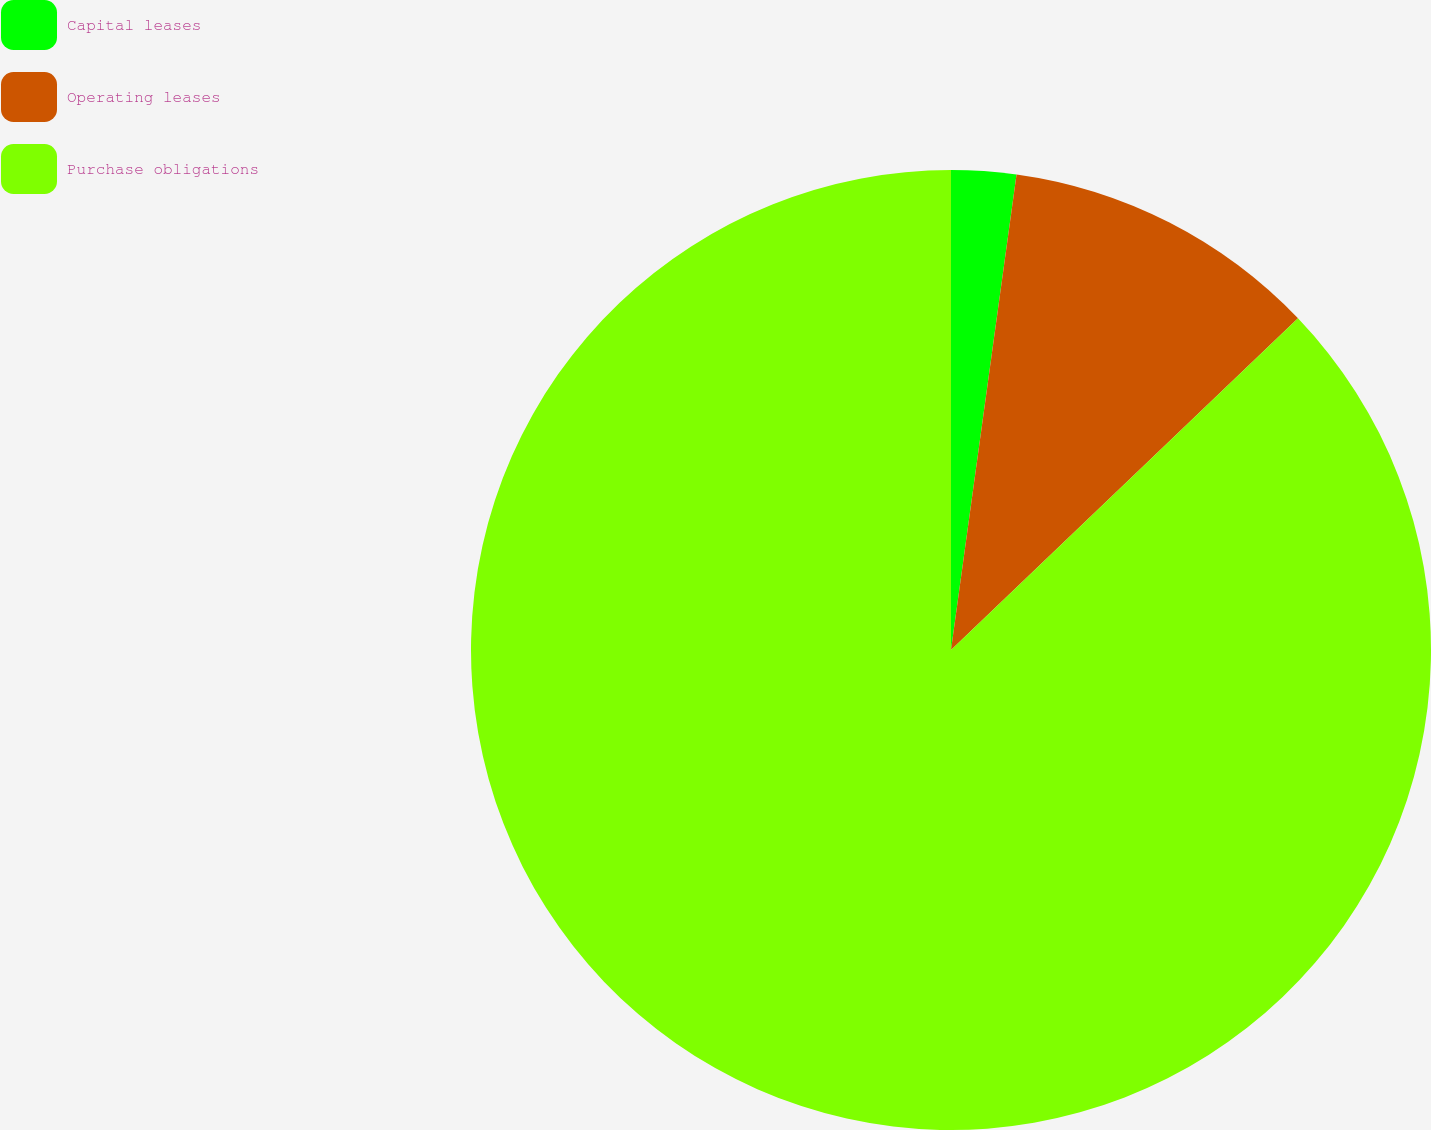Convert chart to OTSL. <chart><loc_0><loc_0><loc_500><loc_500><pie_chart><fcel>Capital leases<fcel>Operating leases<fcel>Purchase obligations<nl><fcel>2.18%<fcel>10.68%<fcel>87.14%<nl></chart> 